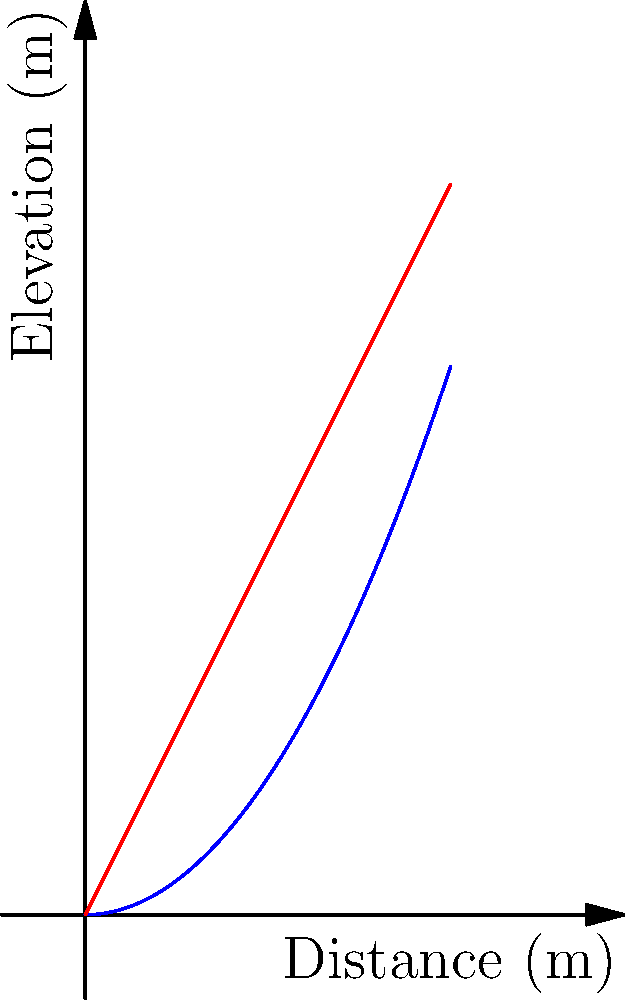Given the terrain contour shown in blue and a proposed linear drainage system in red, determine the optimal slope for the drainage system at a distance of 2 meters from the origin. The terrain contour is described by the function $y = 0.5x^2$, and the drainage system by $y = 2x$. What is the difference in elevation between the terrain and the drainage system at this point? To solve this problem, we'll follow these steps:

1. Calculate the elevation of the terrain at x = 2m:
   $y_{terrain} = 0.5x^2 = 0.5(2)^2 = 0.5(4) = 2$ meters

2. Calculate the elevation of the drainage system at x = 2m:
   $y_{drainage} = 2x = 2(2) = 4$ meters

3. Calculate the difference in elevation:
   $\Delta y = y_{drainage} - y_{terrain} = 4 - 2 = 2$ meters

This difference represents the depth of the drainage system below the terrain surface at the 2-meter mark. A positive value indicates that the drainage system is below the terrain, which is desirable for proper water flow.

4. To determine if this slope is optimal, we'd need to consider factors such as:
   - Minimum slope required for adequate water flow
   - Maximum allowable slope to prevent erosion
   - Cost of excavation
   - Environmental impact

However, given the limited information and the nature of the question, we can conclude that the 2-meter difference provides a significant slope for water drainage while remaining within reasonable excavation depths for most drainage systems.
Answer: 2 meters 